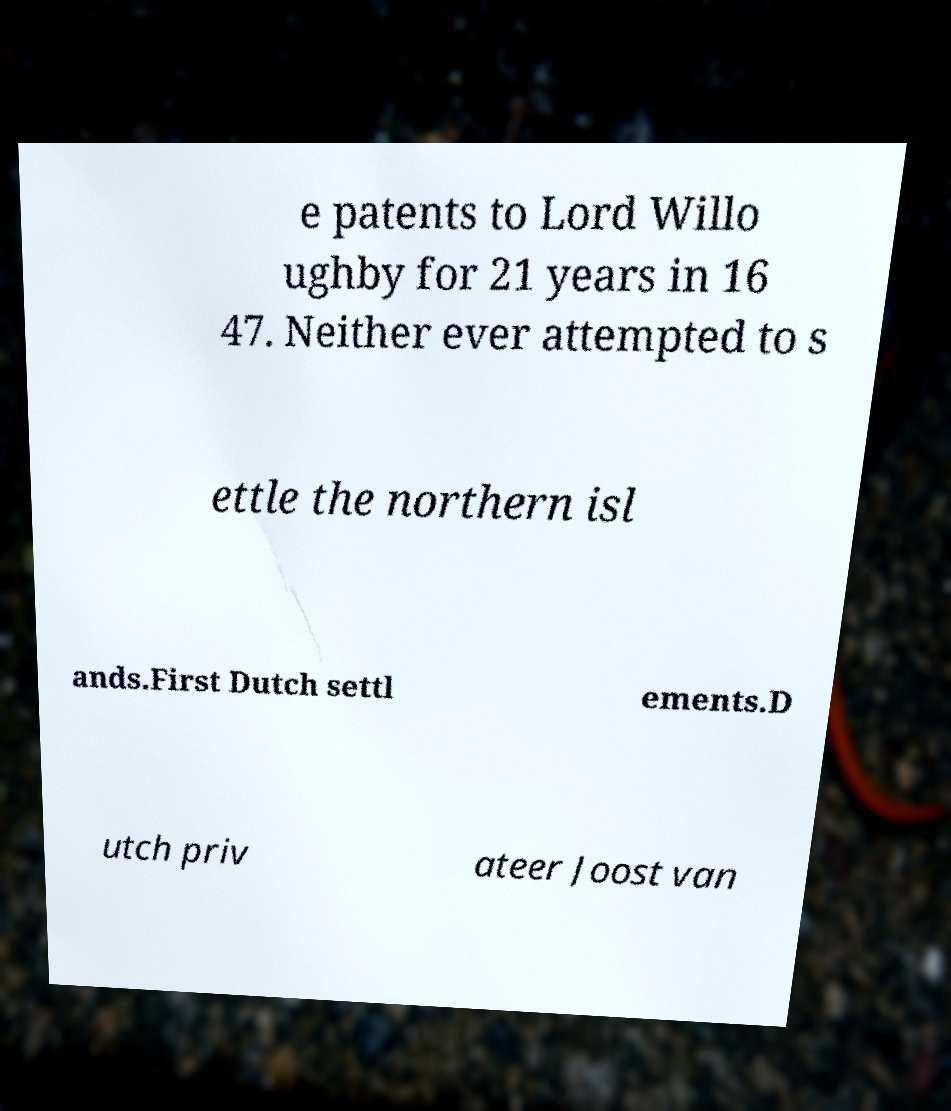Could you assist in decoding the text presented in this image and type it out clearly? e patents to Lord Willo ughby for 21 years in 16 47. Neither ever attempted to s ettle the northern isl ands.First Dutch settl ements.D utch priv ateer Joost van 